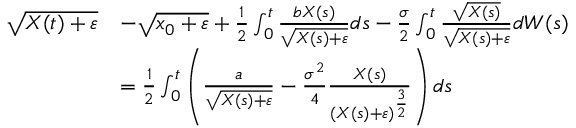Convert formula to latex. <formula><loc_0><loc_0><loc_500><loc_500>\begin{array} { r l } { \sqrt { X ( t ) + \varepsilon } } & { - \sqrt { x _ { 0 } + \varepsilon } + \frac { 1 } { 2 } \int _ { 0 } ^ { t } \frac { b X ( s ) } { \sqrt { X ( s ) + \varepsilon } } d s - \frac { \sigma } { 2 } \int _ { 0 } ^ { t } \frac { \sqrt { X ( s ) } } { \sqrt { X ( s ) + \varepsilon } } d W ( s ) } \\ & { = \frac { 1 } { 2 } \int _ { 0 } ^ { t } \left ( \frac { a } { \sqrt { X ( s ) + \varepsilon } } - \frac { \sigma ^ { 2 } } { 4 } \frac { X ( s ) } { ( X ( s ) + \varepsilon ) ^ { \frac { 3 } { 2 } } } \right ) d s } \end{array}</formula> 